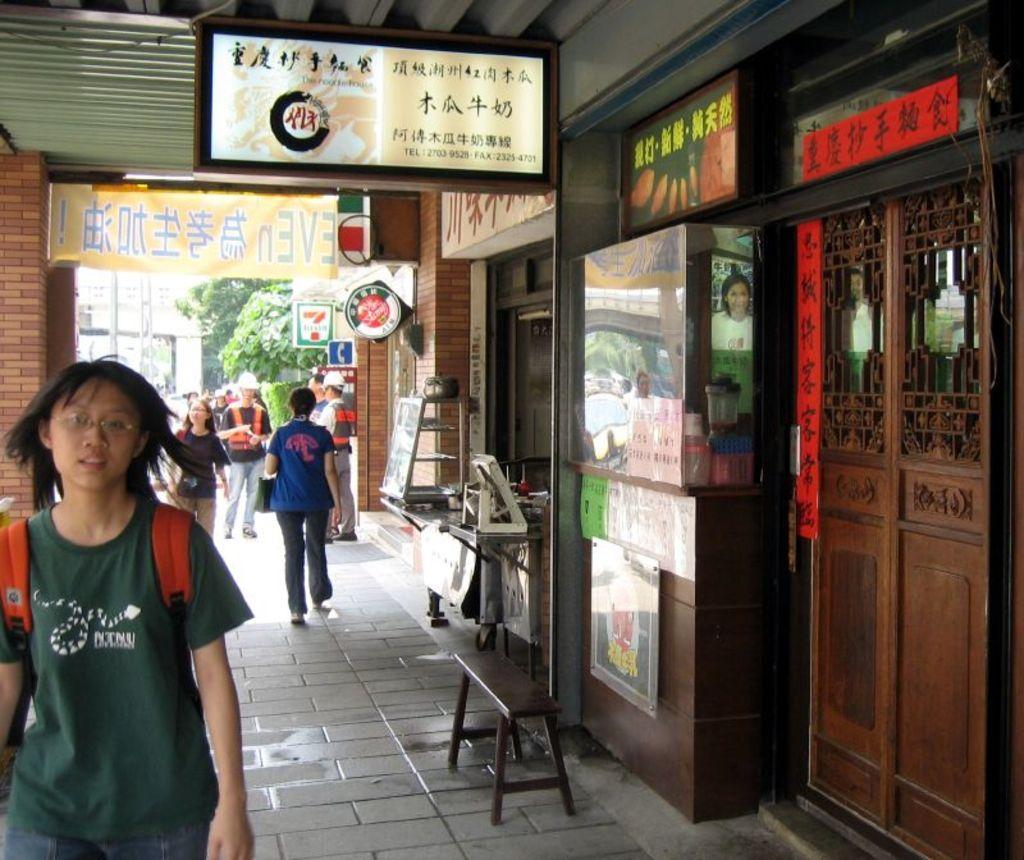How would you summarize this image in a sentence or two? This image consists of stores on the right side. There are so many persons walking in the middle. They are wearing backpacks. There are trees in the middle. 